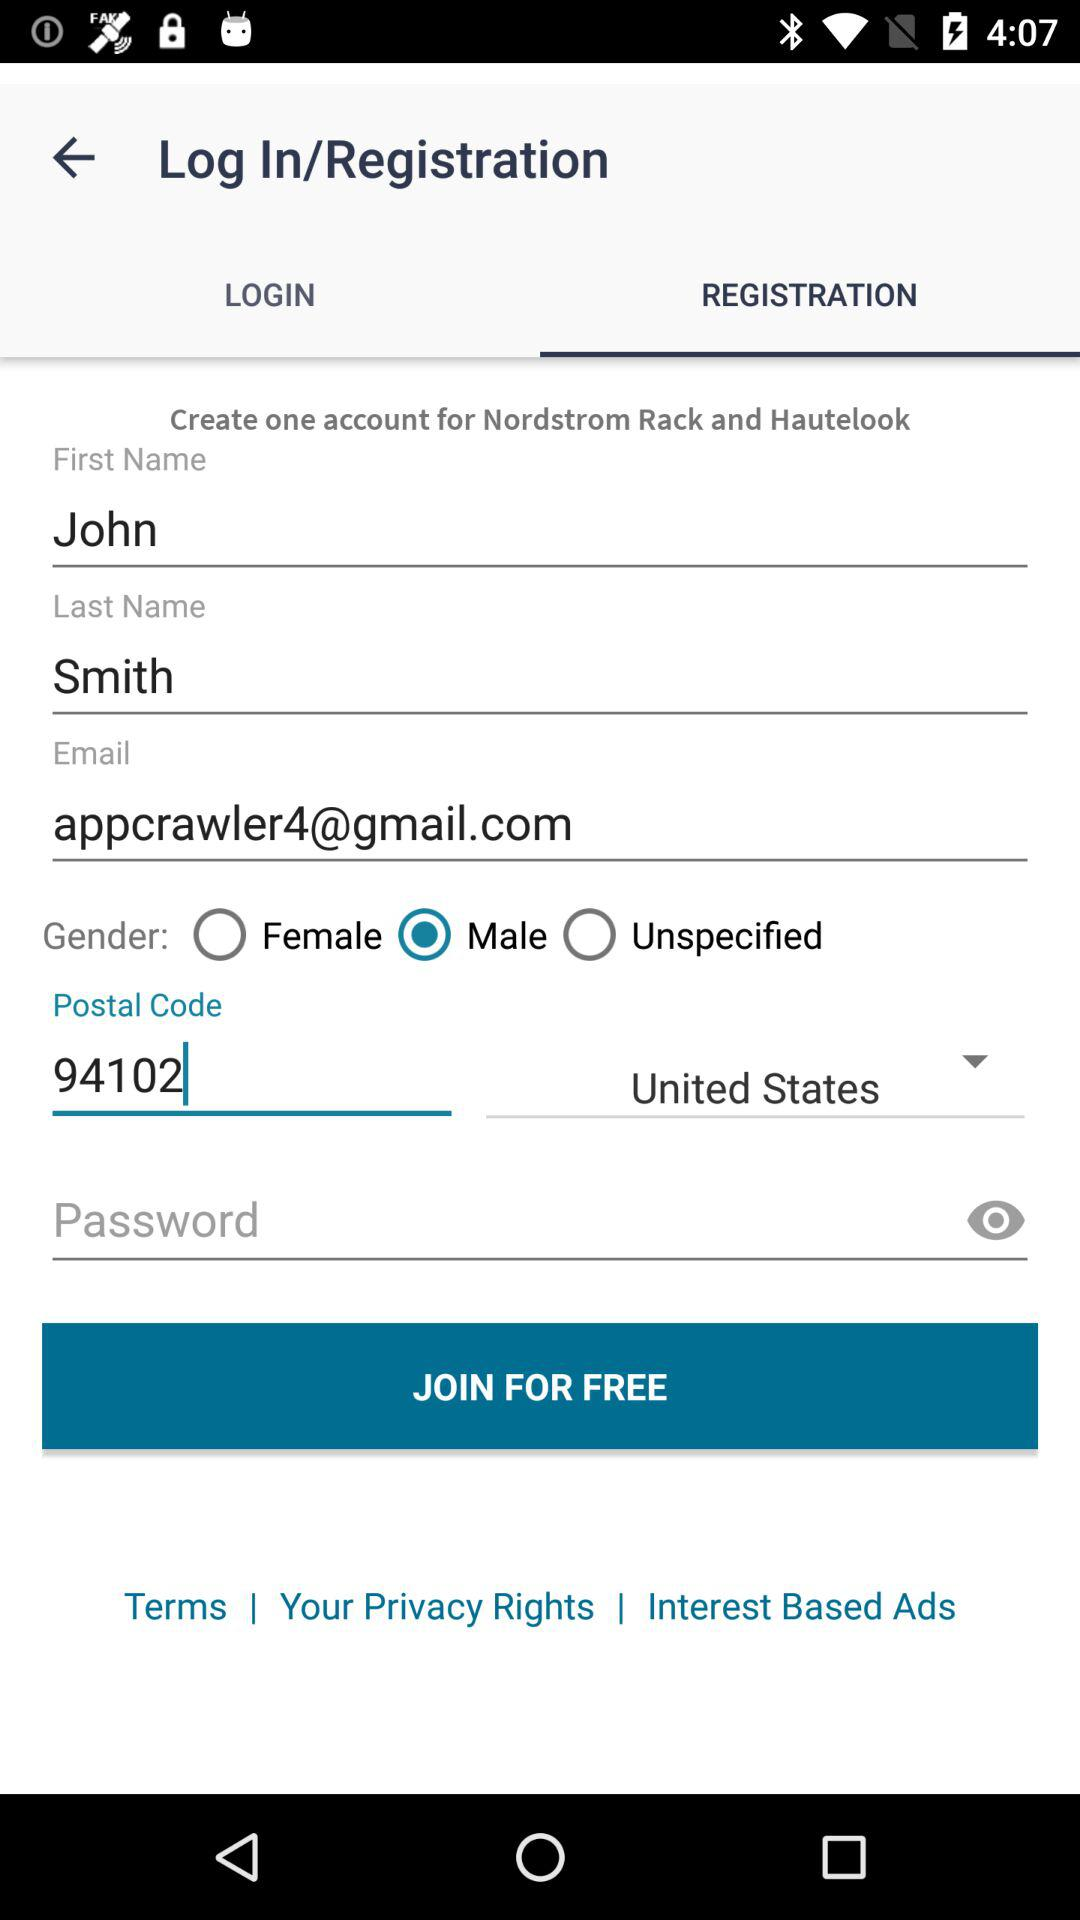What is the postal code? The postal code is 94102. 